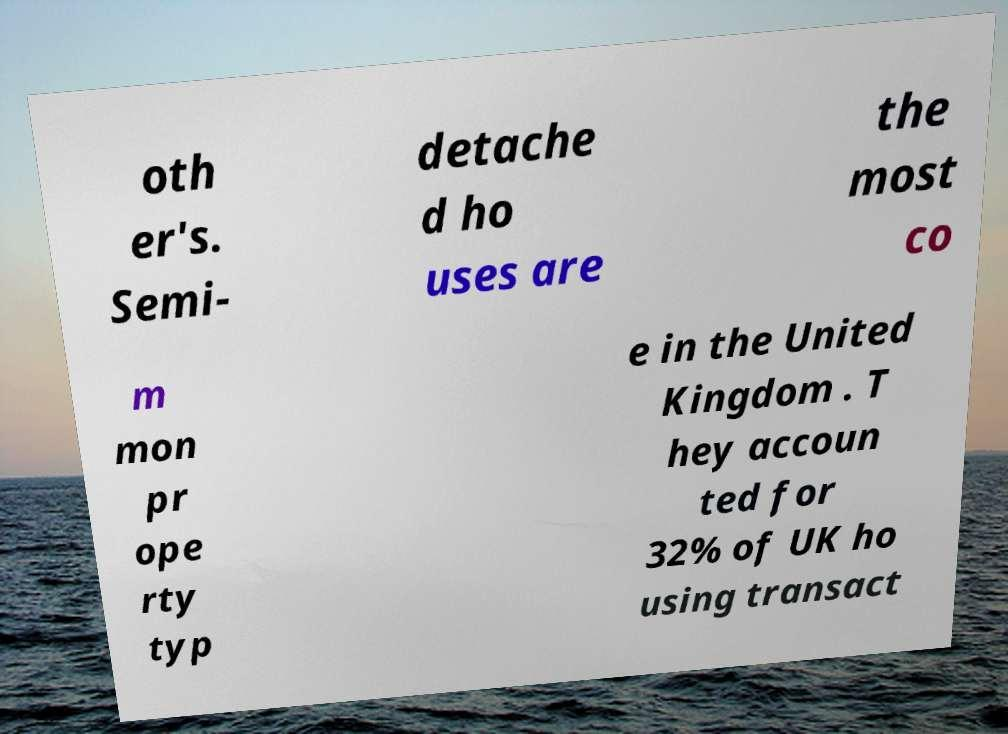Can you accurately transcribe the text from the provided image for me? oth er's. Semi- detache d ho uses are the most co m mon pr ope rty typ e in the United Kingdom . T hey accoun ted for 32% of UK ho using transact 